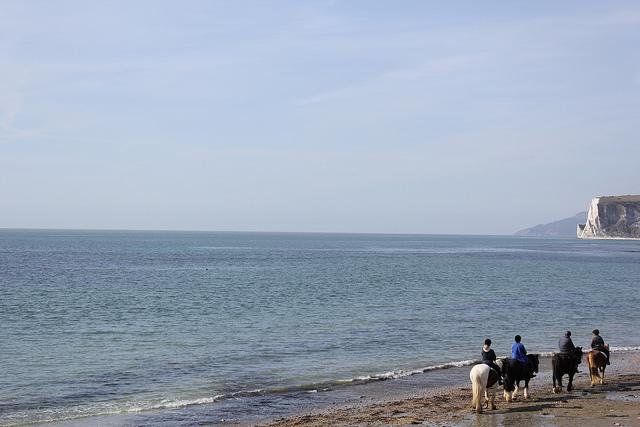What is the first terrain on the right?

Choices:
A) cliff
B) savanna
C) valley
D) mountain cliff 